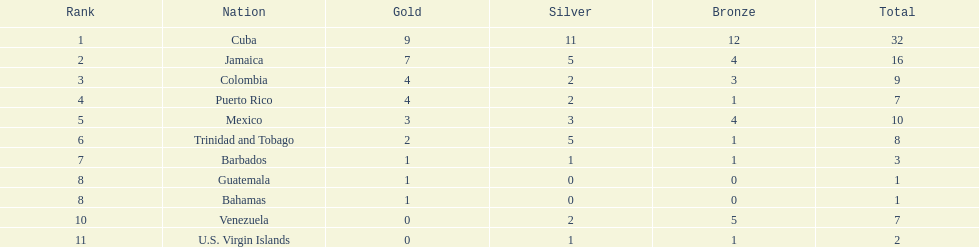Which country was awarded more than 5 silver medals? Cuba. 